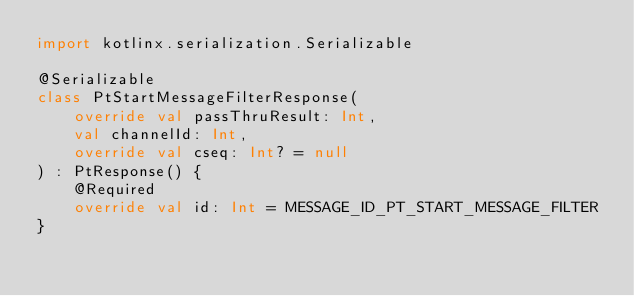Convert code to text. <code><loc_0><loc_0><loc_500><loc_500><_Kotlin_>import kotlinx.serialization.Serializable

@Serializable
class PtStartMessageFilterResponse(
    override val passThruResult: Int,
    val channelId: Int,
    override val cseq: Int? = null
) : PtResponse() {
    @Required
    override val id: Int = MESSAGE_ID_PT_START_MESSAGE_FILTER
}</code> 